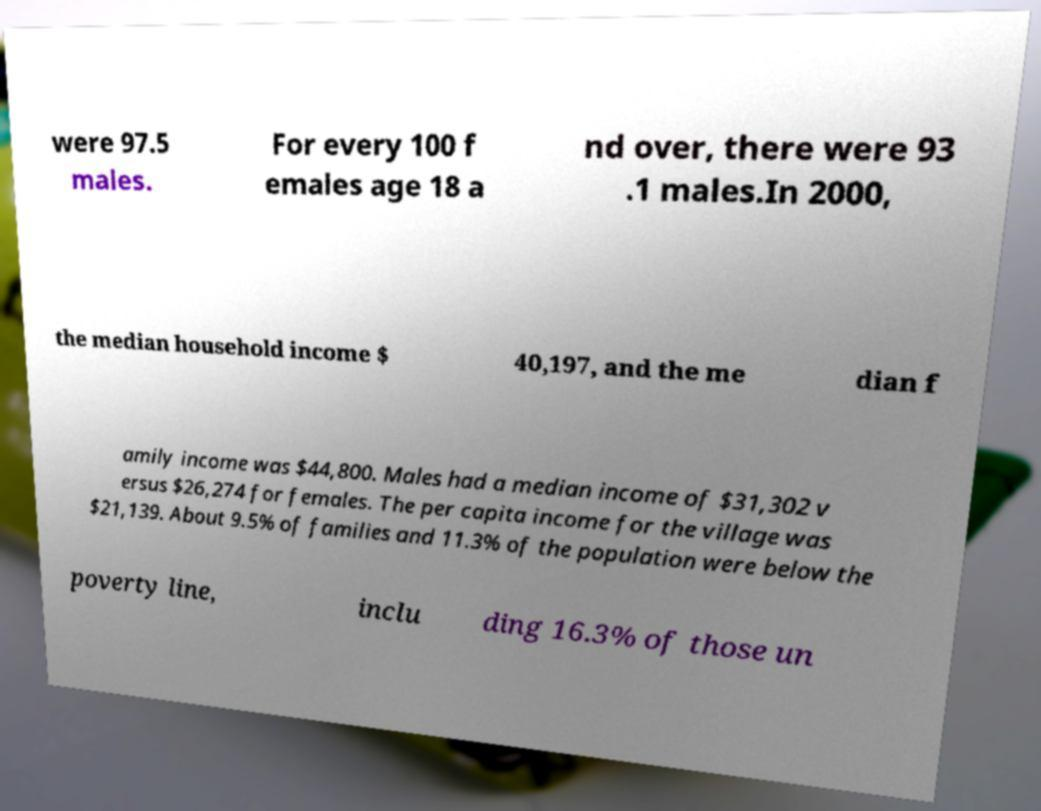Can you read and provide the text displayed in the image?This photo seems to have some interesting text. Can you extract and type it out for me? were 97.5 males. For every 100 f emales age 18 a nd over, there were 93 .1 males.In 2000, the median household income $ 40,197, and the me dian f amily income was $44,800. Males had a median income of $31,302 v ersus $26,274 for females. The per capita income for the village was $21,139. About 9.5% of families and 11.3% of the population were below the poverty line, inclu ding 16.3% of those un 